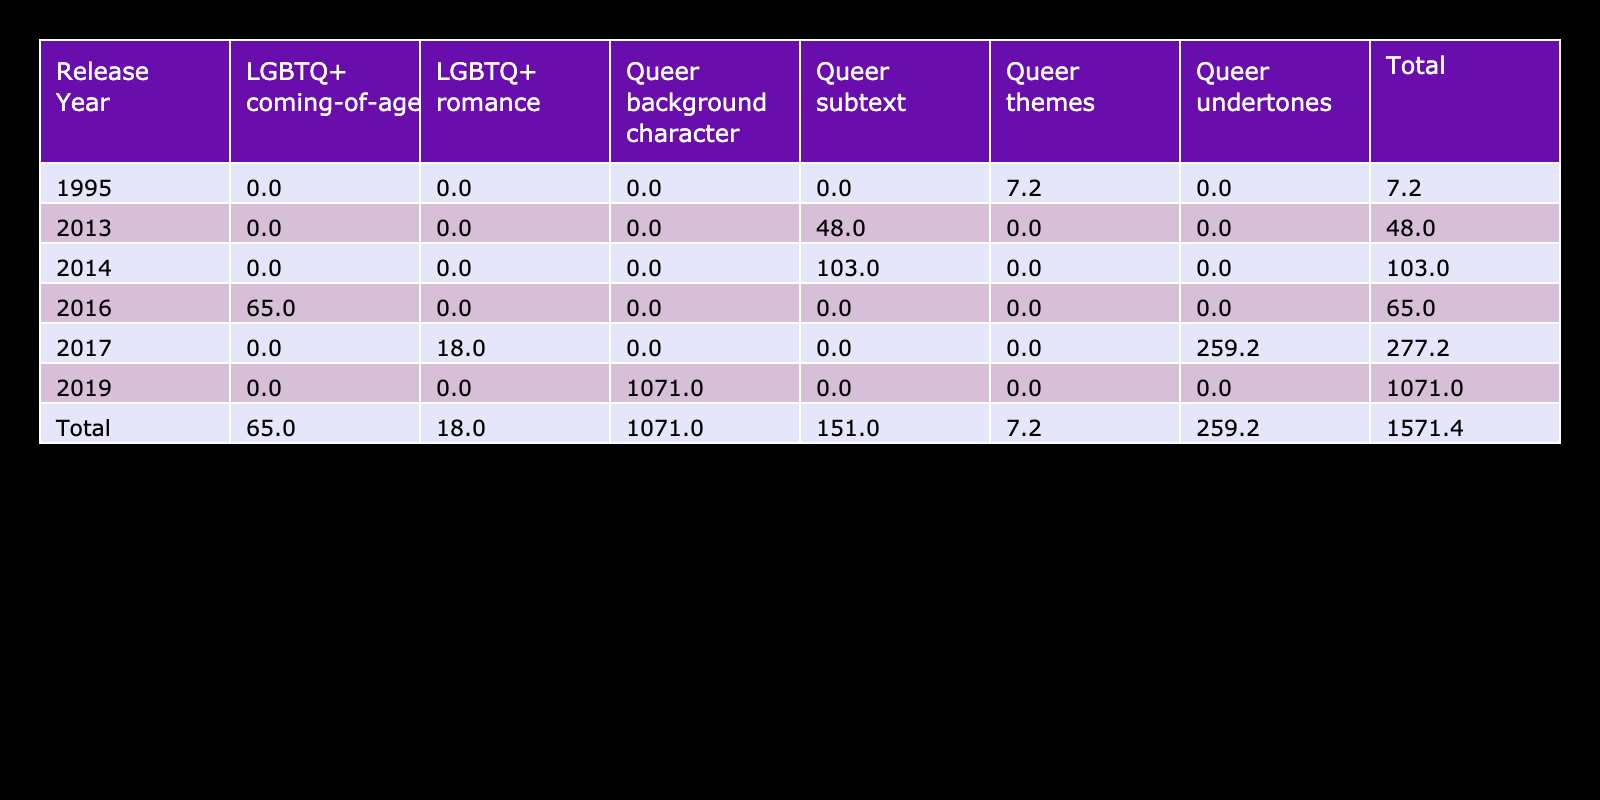What is the total box office performance for films with LGBTQ+ romance representation? The film with LGBTQ+ romance representation is "Call Me by Your Name," which has a box office performance of 18.0 million USD. Thus, the total box office performance for this representation type is 18.0 million USD, as it is the only film of this type in the data.
Answer: 18.0 million USD Which film released in 2019 had the highest box office performance? In the table, "Star Wars: The Rise of Skywalker" is the only film listed for 2019, and it has a box office performance of 1071.0 million USD, making it the highest box office performance in that year.
Answer: 1071.0 million USD What is the average box office performance for queer-themed films? The queer-themed films and their performances are "Strange Days" (7.2), "Blade Runner 2049" (259.2), and "Her" (48.0). Adding these, we get 7.2 + 259.2 + 48.0 = 314.4 million USD. There are 3 films, so the average is 314.4 / 3 = 104.8 million USD.
Answer: 104.8 million USD Did any film released after 2016 have a box office performance below 100 million USD? Looking at the post-2016 released films, "Call Me by Your Name" (18.0) and "Her" (48.0) both fall below 100 million USD, confirming that yes, there are films released after 2016 with such performance.
Answer: Yes What is the difference in box office performance between the highest and lowest performing queer representation types in the film released in 2017? In 2017, the films are "Call Me by Your Name" (18.0 million USD) and "Blade Runner 2049" (259.2 million USD). The difference is calculated as 259.2 - 18.0 = 241.2 million USD.
Answer: 241.2 million USD How many films in total have queer subtext representation, and what is their combined box office performance? The films with queer subtext representation are "Her" (48.0 million USD) and "Transcendence" (103.0 million USD). There are 2 such films, and their combined box office performance is 48.0 + 103.0 = 151.0 million USD.
Answer: 2 films, 151.0 million USD Was there a film directed by a female director that reached above 100 million USD in box office performance? The film "Blade Runner 2049" directed by Denis Villeneuve reached 259.2 million USD, but "Strange Days" directed by Kathryn Bigelow only reached 7.2 million USD. Therefore, no, there is no film directed by a female director above 100 million USD.
Answer: No What is the box office performance of films released in 2016 compared to those in 2017? The film "Moonlight" from 2016 had a performance of 65.0 million USD, while in 2017, "Call Me by Your Name" performed at 18.0 million USD and "Blade Runner 2049" at 259.2 million USD. The total for 2017 is 18.0 + 259.2 = 277.2 million USD compared to 65.0 million USD for 2016. So, 2017 outperformed 2016 significantly.
Answer: 2017 outperformed 2016 